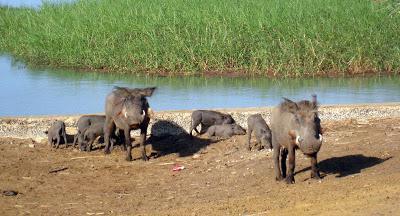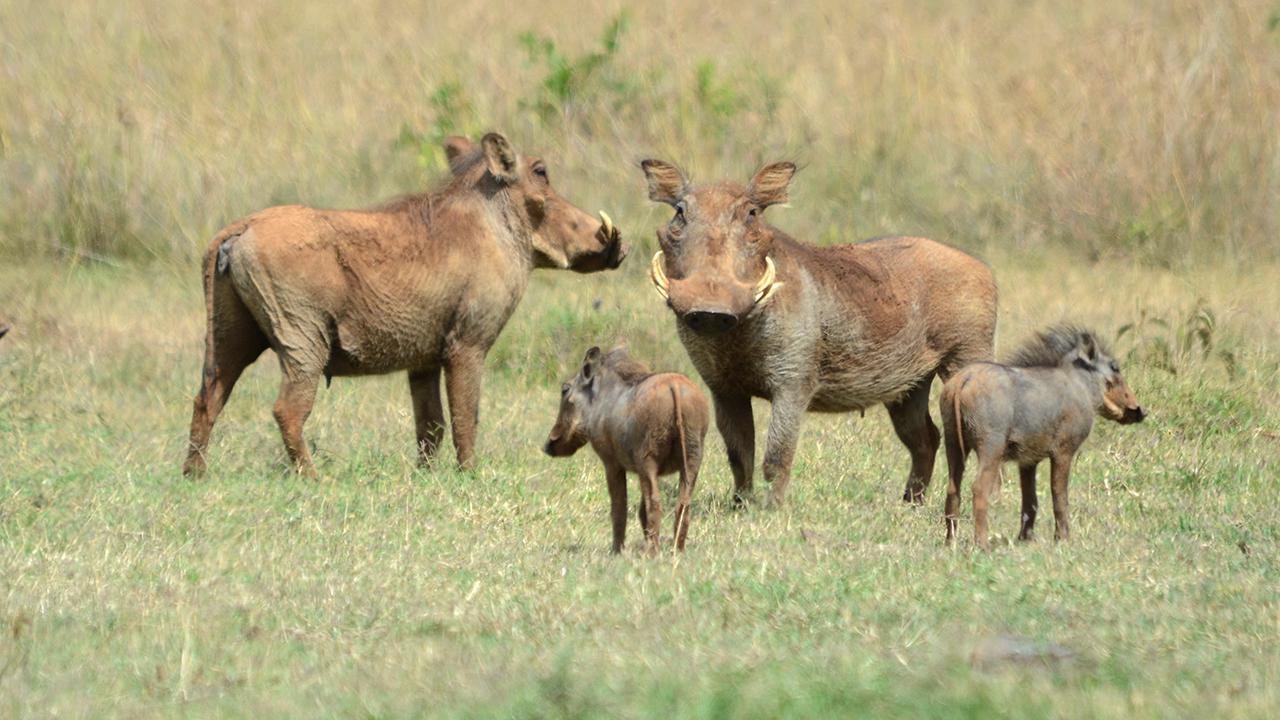The first image is the image on the left, the second image is the image on the right. Analyze the images presented: Is the assertion "There is water in the image on the left." valid? Answer yes or no. Yes. The first image is the image on the left, the second image is the image on the right. Considering the images on both sides, is "In one of the images there is a group of warthogs standing near water." valid? Answer yes or no. Yes. 